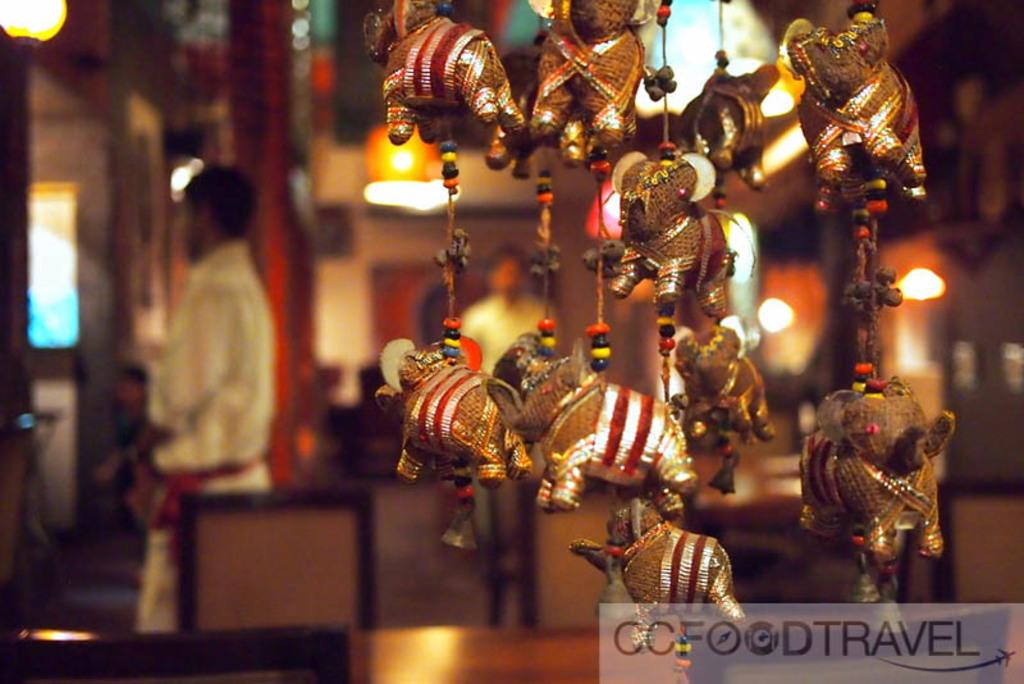What type of toys are featured in the image? There are toy elephants in the image. How are the toy elephants displayed or arranged? The toy elephants are hanged with threads and beads. Can you describe the background of the image? The background of the image is blurry. Are there any people visible in the image? Yes, there are people visible in the background. What other objects or features can be seen in the image? There are lights and text at the bottom of the image. What type of badge is the rat wearing in the image? There is no rat or badge present in the image. Can you describe the facial expressions of the people in the image? The provided facts do not mention facial expressions, only the presence of people in the background. 